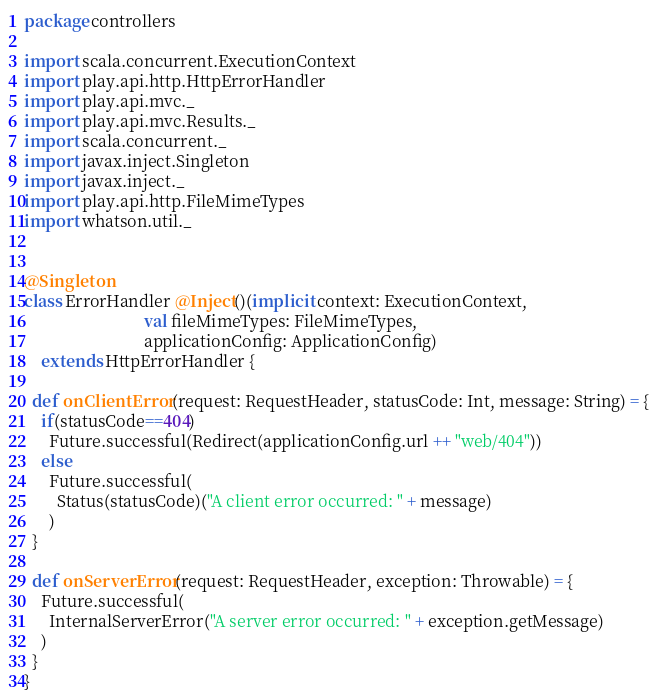Convert code to text. <code><loc_0><loc_0><loc_500><loc_500><_Scala_>package controllers

import scala.concurrent.ExecutionContext
import play.api.http.HttpErrorHandler
import play.api.mvc._
import play.api.mvc.Results._
import scala.concurrent._
import javax.inject.Singleton
import javax.inject._
import play.api.http.FileMimeTypes
import whatson.util._


@Singleton
class ErrorHandler @Inject()(implicit context: ExecutionContext,
                             val fileMimeTypes: FileMimeTypes,
                             applicationConfig: ApplicationConfig)
    extends HttpErrorHandler {

  def onClientError(request: RequestHeader, statusCode: Int, message: String) = {
    if(statusCode==404)
      Future.successful(Redirect(applicationConfig.url ++ "web/404"))
    else
      Future.successful(
        Status(statusCode)("A client error occurred: " + message)
      )
  }

  def onServerError(request: RequestHeader, exception: Throwable) = {
    Future.successful(
      InternalServerError("A server error occurred: " + exception.getMessage)
    )
  }
}
</code> 